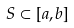Convert formula to latex. <formula><loc_0><loc_0><loc_500><loc_500>S \subset [ a , b ]</formula> 